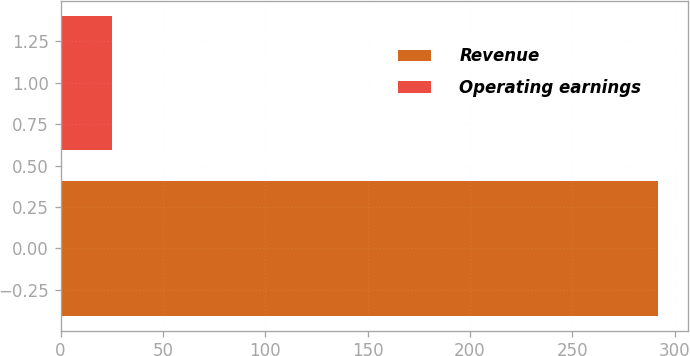<chart> <loc_0><loc_0><loc_500><loc_500><bar_chart><fcel>Revenue<fcel>Operating earnings<nl><fcel>292<fcel>25<nl></chart> 